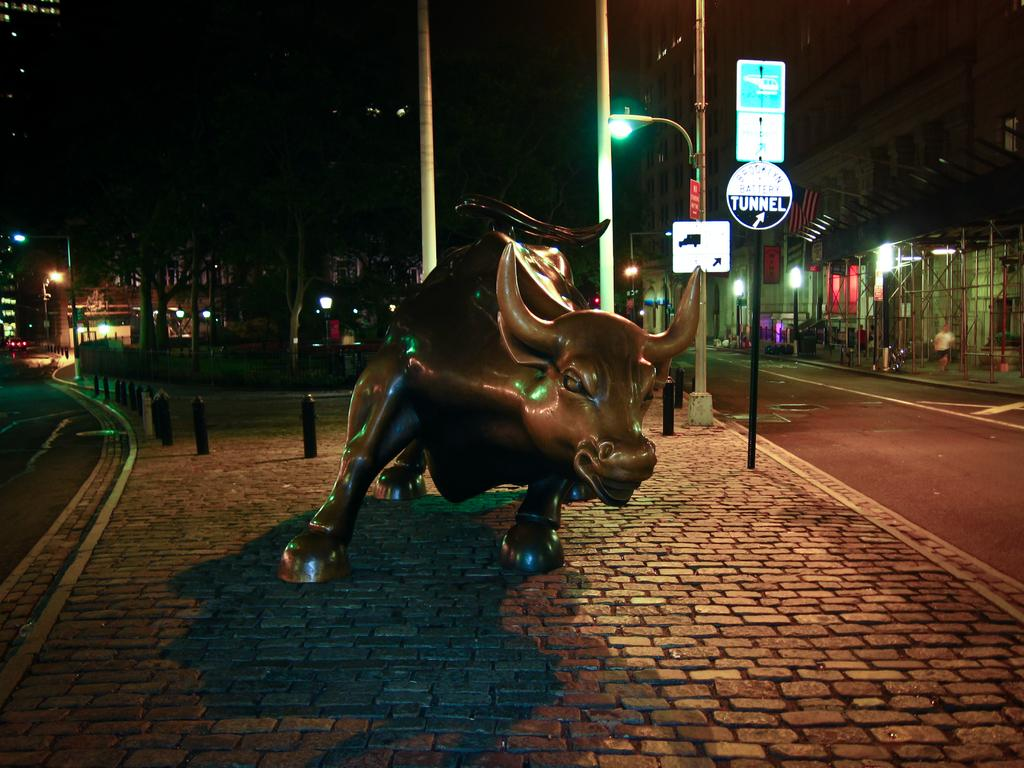What is the main subject of the image? The main subject of the image is a sculpture of a bull on the surface. What other objects can be seen in the image? There are poles, boards, and lights on the poles in the image. What is visible in the background of the image? There are buildings, people, more poles, lights, and trees in the background. What type of home can be seen in the background of the image? There is no home visible in the background of the image. What form does the boot take in the image? There is no boot present in the image. 